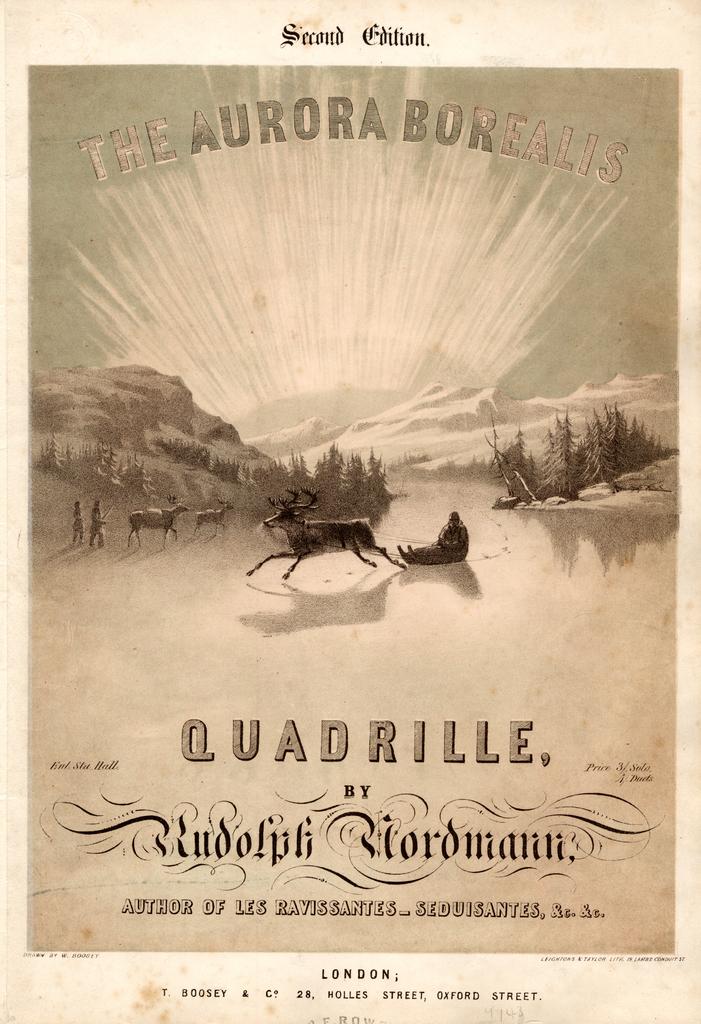What is the name of the author?
Your response must be concise. Rudolph nordmann. Which edition is this?
Your answer should be compact. Second. 